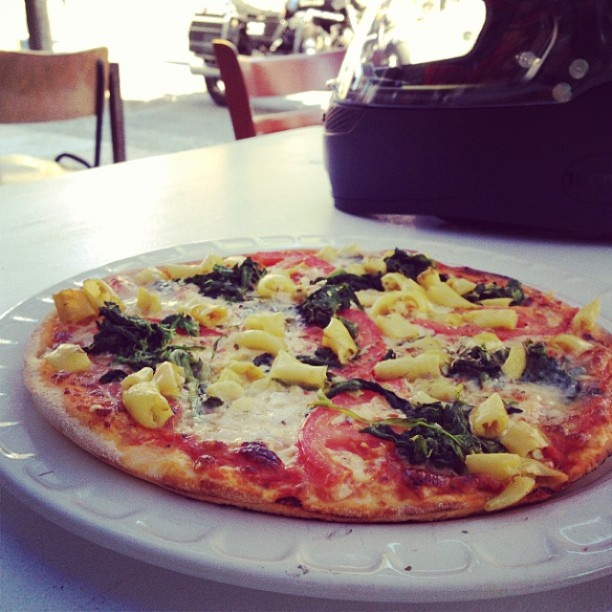Describe the objects in this image and their specific colors. I can see dining table in white, darkgray, beige, brown, and tan tones, pizza in ivory, brown, tan, and black tones, chair in white, brown, beige, and tan tones, chair in white, tan, darkgray, purple, and brown tones, and motorcycle in white, ivory, gray, darkgray, and beige tones in this image. 